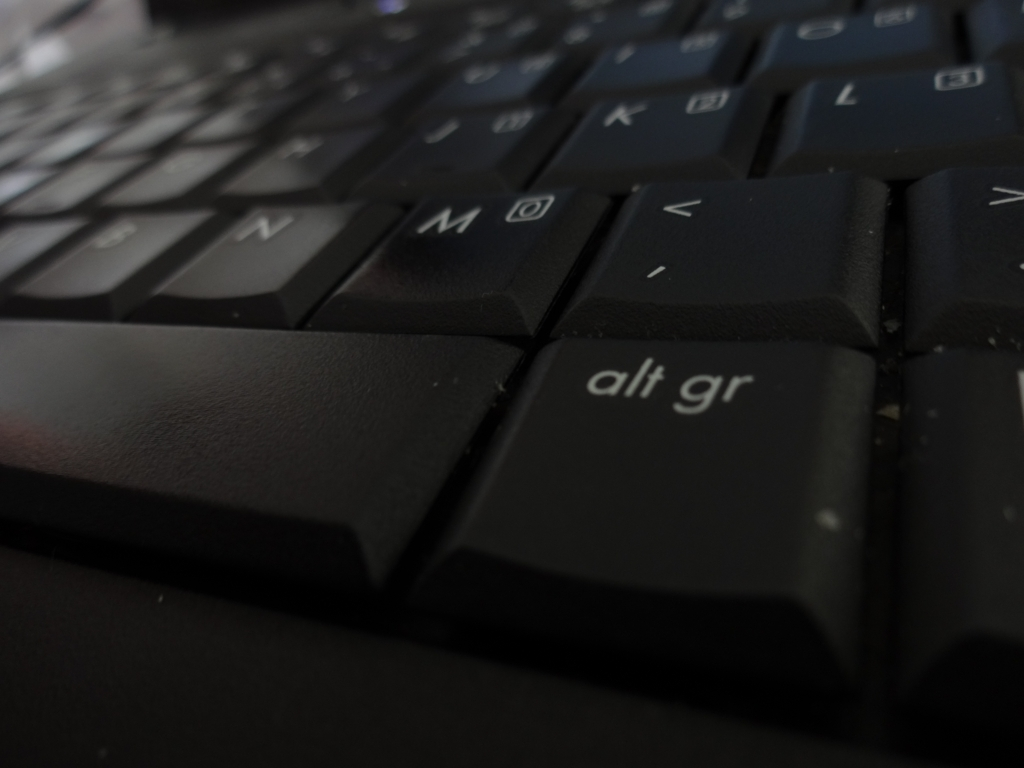How do the lighting conditions affect the mood or usability of this keyboard? The lighting in the image is dim, creating a moody atmosphere that could affect the usability of the keyboard. In darker settings, it may be harder to distinguish the keys, which could lead to typing errors or strain on the eyes. However, the illuminated characters on the keys suggest that this keyboard is designed to be usable even in lower light conditions. 